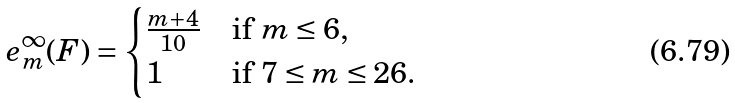<formula> <loc_0><loc_0><loc_500><loc_500>e _ { m } ^ { \infty } ( F ) = \begin{cases} \frac { m + 4 } { 1 0 } & \text {if $m \leq 6,$} \\ 1 & \text {if $7 \leq m \leq 26.$} \end{cases}</formula> 